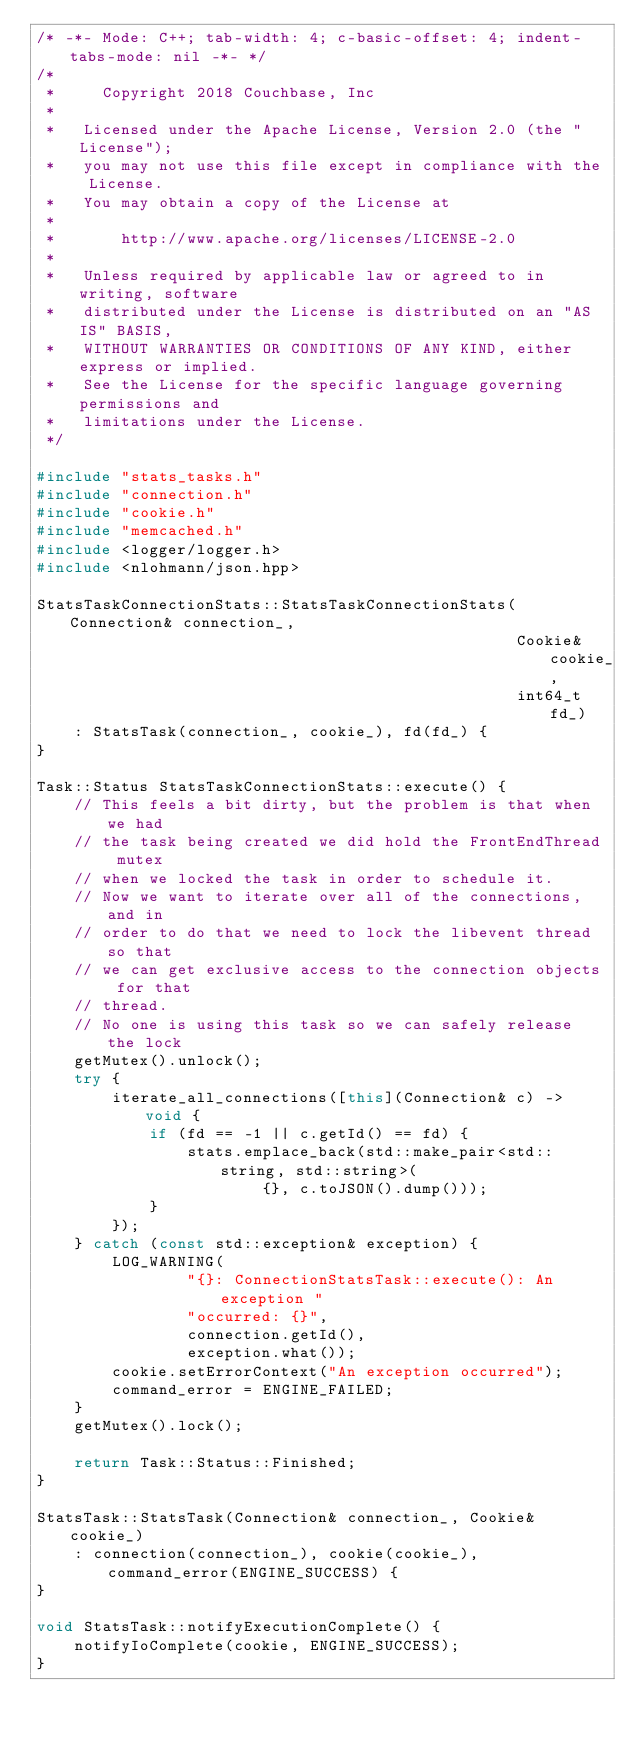Convert code to text. <code><loc_0><loc_0><loc_500><loc_500><_C++_>/* -*- Mode: C++; tab-width: 4; c-basic-offset: 4; indent-tabs-mode: nil -*- */
/*
 *     Copyright 2018 Couchbase, Inc
 *
 *   Licensed under the Apache License, Version 2.0 (the "License");
 *   you may not use this file except in compliance with the License.
 *   You may obtain a copy of the License at
 *
 *       http://www.apache.org/licenses/LICENSE-2.0
 *
 *   Unless required by applicable law or agreed to in writing, software
 *   distributed under the License is distributed on an "AS IS" BASIS,
 *   WITHOUT WARRANTIES OR CONDITIONS OF ANY KIND, either express or implied.
 *   See the License for the specific language governing permissions and
 *   limitations under the License.
 */

#include "stats_tasks.h"
#include "connection.h"
#include "cookie.h"
#include "memcached.h"
#include <logger/logger.h>
#include <nlohmann/json.hpp>

StatsTaskConnectionStats::StatsTaskConnectionStats(Connection& connection_,
                                                   Cookie& cookie_,
                                                   int64_t fd_)
    : StatsTask(connection_, cookie_), fd(fd_) {
}

Task::Status StatsTaskConnectionStats::execute() {
    // This feels a bit dirty, but the problem is that when we had
    // the task being created we did hold the FrontEndThread mutex
    // when we locked the task in order to schedule it.
    // Now we want to iterate over all of the connections, and in
    // order to do that we need to lock the libevent thread so that
    // we can get exclusive access to the connection objects for that
    // thread.
    // No one is using this task so we can safely release the lock
    getMutex().unlock();
    try {
        iterate_all_connections([this](Connection& c) -> void {
            if (fd == -1 || c.getId() == fd) {
                stats.emplace_back(std::make_pair<std::string, std::string>(
                        {}, c.toJSON().dump()));
            }
        });
    } catch (const std::exception& exception) {
        LOG_WARNING(
                "{}: ConnectionStatsTask::execute(): An exception "
                "occurred: {}",
                connection.getId(),
                exception.what());
        cookie.setErrorContext("An exception occurred");
        command_error = ENGINE_FAILED;
    }
    getMutex().lock();

    return Task::Status::Finished;
}

StatsTask::StatsTask(Connection& connection_, Cookie& cookie_)
    : connection(connection_), cookie(cookie_), command_error(ENGINE_SUCCESS) {
}

void StatsTask::notifyExecutionComplete() {
    notifyIoComplete(cookie, ENGINE_SUCCESS);
}
</code> 